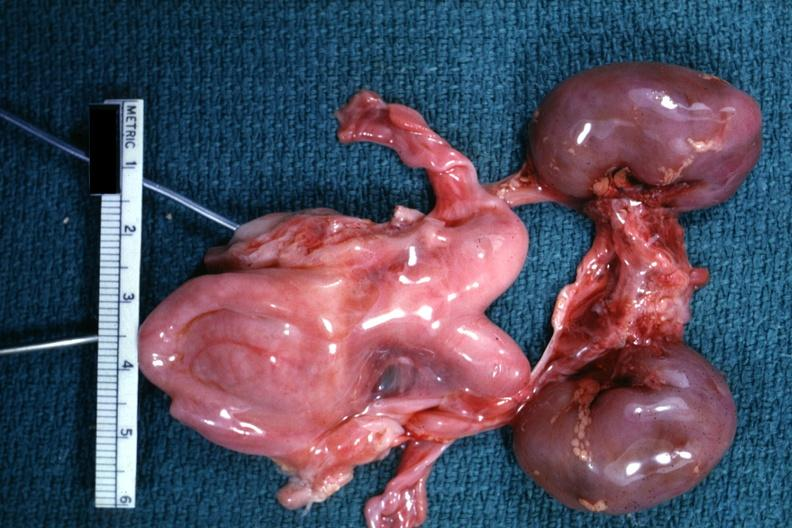s female reproductive present?
Answer the question using a single word or phrase. Yes 